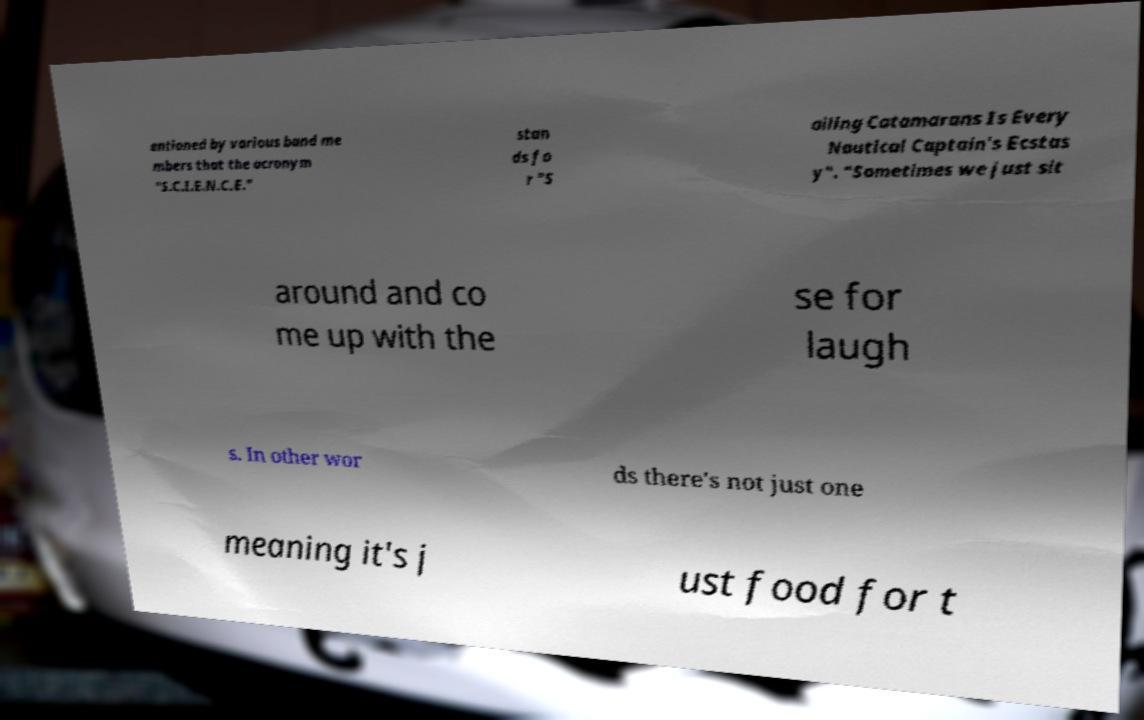Please read and relay the text visible in this image. What does it say? entioned by various band me mbers that the acronym "S.C.I.E.N.C.E." stan ds fo r "S ailing Catamarans Is Every Nautical Captain's Ecstas y". "Sometimes we just sit around and co me up with the se for laugh s. In other wor ds there's not just one meaning it's j ust food for t 